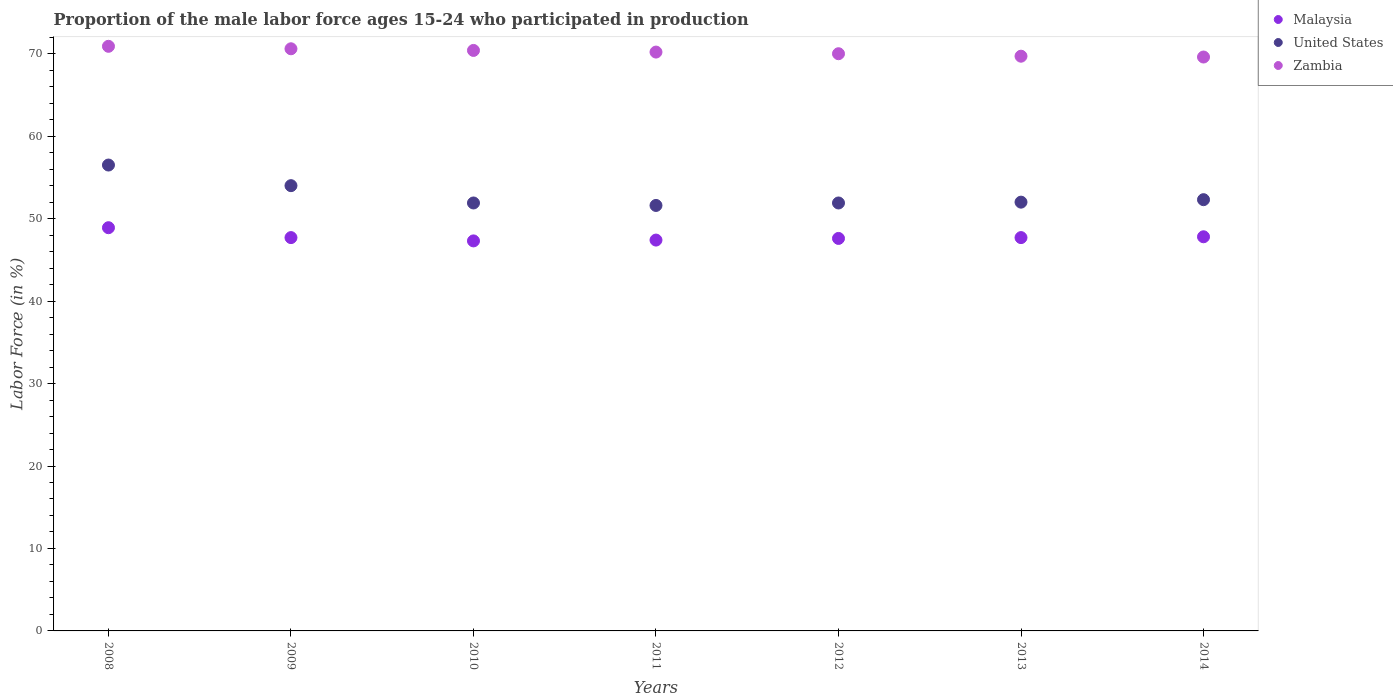How many different coloured dotlines are there?
Ensure brevity in your answer.  3. Is the number of dotlines equal to the number of legend labels?
Provide a succinct answer. Yes. What is the proportion of the male labor force who participated in production in United States in 2008?
Your response must be concise. 56.5. Across all years, what is the maximum proportion of the male labor force who participated in production in United States?
Give a very brief answer. 56.5. Across all years, what is the minimum proportion of the male labor force who participated in production in Zambia?
Your answer should be very brief. 69.6. In which year was the proportion of the male labor force who participated in production in Malaysia minimum?
Keep it short and to the point. 2010. What is the total proportion of the male labor force who participated in production in Zambia in the graph?
Provide a short and direct response. 491.4. What is the difference between the proportion of the male labor force who participated in production in United States in 2011 and the proportion of the male labor force who participated in production in Malaysia in 2008?
Make the answer very short. 2.7. What is the average proportion of the male labor force who participated in production in United States per year?
Give a very brief answer. 52.89. In the year 2011, what is the difference between the proportion of the male labor force who participated in production in Zambia and proportion of the male labor force who participated in production in United States?
Your response must be concise. 18.6. What is the ratio of the proportion of the male labor force who participated in production in United States in 2013 to that in 2014?
Offer a terse response. 0.99. Is the proportion of the male labor force who participated in production in Malaysia in 2013 less than that in 2014?
Provide a succinct answer. Yes. Is the difference between the proportion of the male labor force who participated in production in Zambia in 2009 and 2014 greater than the difference between the proportion of the male labor force who participated in production in United States in 2009 and 2014?
Your response must be concise. No. What is the difference between the highest and the second highest proportion of the male labor force who participated in production in Malaysia?
Your answer should be very brief. 1.1. What is the difference between the highest and the lowest proportion of the male labor force who participated in production in United States?
Give a very brief answer. 4.9. In how many years, is the proportion of the male labor force who participated in production in Zambia greater than the average proportion of the male labor force who participated in production in Zambia taken over all years?
Offer a very short reply. 3. Is it the case that in every year, the sum of the proportion of the male labor force who participated in production in United States and proportion of the male labor force who participated in production in Zambia  is greater than the proportion of the male labor force who participated in production in Malaysia?
Your answer should be compact. Yes. Is the proportion of the male labor force who participated in production in United States strictly greater than the proportion of the male labor force who participated in production in Zambia over the years?
Your answer should be compact. No. Is the proportion of the male labor force who participated in production in Zambia strictly less than the proportion of the male labor force who participated in production in United States over the years?
Give a very brief answer. No. How many years are there in the graph?
Make the answer very short. 7. Does the graph contain grids?
Your answer should be very brief. No. How many legend labels are there?
Offer a terse response. 3. How are the legend labels stacked?
Keep it short and to the point. Vertical. What is the title of the graph?
Provide a short and direct response. Proportion of the male labor force ages 15-24 who participated in production. What is the Labor Force (in %) of Malaysia in 2008?
Offer a very short reply. 48.9. What is the Labor Force (in %) of United States in 2008?
Provide a succinct answer. 56.5. What is the Labor Force (in %) of Zambia in 2008?
Keep it short and to the point. 70.9. What is the Labor Force (in %) in Malaysia in 2009?
Your answer should be compact. 47.7. What is the Labor Force (in %) in United States in 2009?
Give a very brief answer. 54. What is the Labor Force (in %) of Zambia in 2009?
Provide a succinct answer. 70.6. What is the Labor Force (in %) in Malaysia in 2010?
Offer a terse response. 47.3. What is the Labor Force (in %) of United States in 2010?
Your answer should be compact. 51.9. What is the Labor Force (in %) in Zambia in 2010?
Your answer should be compact. 70.4. What is the Labor Force (in %) in Malaysia in 2011?
Provide a short and direct response. 47.4. What is the Labor Force (in %) of United States in 2011?
Your answer should be very brief. 51.6. What is the Labor Force (in %) in Zambia in 2011?
Offer a terse response. 70.2. What is the Labor Force (in %) of Malaysia in 2012?
Your answer should be very brief. 47.6. What is the Labor Force (in %) of United States in 2012?
Your response must be concise. 51.9. What is the Labor Force (in %) of Malaysia in 2013?
Provide a succinct answer. 47.7. What is the Labor Force (in %) of United States in 2013?
Give a very brief answer. 52. What is the Labor Force (in %) of Zambia in 2013?
Offer a terse response. 69.7. What is the Labor Force (in %) of Malaysia in 2014?
Your answer should be very brief. 47.8. What is the Labor Force (in %) in United States in 2014?
Give a very brief answer. 52.3. What is the Labor Force (in %) of Zambia in 2014?
Ensure brevity in your answer.  69.6. Across all years, what is the maximum Labor Force (in %) in Malaysia?
Make the answer very short. 48.9. Across all years, what is the maximum Labor Force (in %) in United States?
Make the answer very short. 56.5. Across all years, what is the maximum Labor Force (in %) in Zambia?
Ensure brevity in your answer.  70.9. Across all years, what is the minimum Labor Force (in %) of Malaysia?
Your answer should be very brief. 47.3. Across all years, what is the minimum Labor Force (in %) of United States?
Offer a terse response. 51.6. Across all years, what is the minimum Labor Force (in %) in Zambia?
Offer a very short reply. 69.6. What is the total Labor Force (in %) of Malaysia in the graph?
Offer a terse response. 334.4. What is the total Labor Force (in %) in United States in the graph?
Give a very brief answer. 370.2. What is the total Labor Force (in %) of Zambia in the graph?
Your answer should be very brief. 491.4. What is the difference between the Labor Force (in %) of Malaysia in 2008 and that in 2009?
Your answer should be very brief. 1.2. What is the difference between the Labor Force (in %) of United States in 2008 and that in 2009?
Provide a short and direct response. 2.5. What is the difference between the Labor Force (in %) in United States in 2008 and that in 2010?
Give a very brief answer. 4.6. What is the difference between the Labor Force (in %) in Malaysia in 2008 and that in 2011?
Make the answer very short. 1.5. What is the difference between the Labor Force (in %) in Malaysia in 2008 and that in 2012?
Offer a very short reply. 1.3. What is the difference between the Labor Force (in %) in United States in 2008 and that in 2012?
Offer a very short reply. 4.6. What is the difference between the Labor Force (in %) in Malaysia in 2008 and that in 2013?
Give a very brief answer. 1.2. What is the difference between the Labor Force (in %) of United States in 2008 and that in 2013?
Your answer should be very brief. 4.5. What is the difference between the Labor Force (in %) of Malaysia in 2008 and that in 2014?
Your answer should be compact. 1.1. What is the difference between the Labor Force (in %) of Zambia in 2008 and that in 2014?
Your answer should be very brief. 1.3. What is the difference between the Labor Force (in %) in Malaysia in 2009 and that in 2010?
Offer a terse response. 0.4. What is the difference between the Labor Force (in %) in United States in 2009 and that in 2010?
Offer a very short reply. 2.1. What is the difference between the Labor Force (in %) of Zambia in 2009 and that in 2010?
Provide a succinct answer. 0.2. What is the difference between the Labor Force (in %) of United States in 2009 and that in 2011?
Keep it short and to the point. 2.4. What is the difference between the Labor Force (in %) of Zambia in 2009 and that in 2011?
Provide a succinct answer. 0.4. What is the difference between the Labor Force (in %) in Malaysia in 2009 and that in 2012?
Offer a very short reply. 0.1. What is the difference between the Labor Force (in %) of United States in 2009 and that in 2012?
Ensure brevity in your answer.  2.1. What is the difference between the Labor Force (in %) in Zambia in 2009 and that in 2012?
Provide a succinct answer. 0.6. What is the difference between the Labor Force (in %) of Malaysia in 2009 and that in 2013?
Provide a succinct answer. 0. What is the difference between the Labor Force (in %) of Zambia in 2009 and that in 2013?
Offer a terse response. 0.9. What is the difference between the Labor Force (in %) in Malaysia in 2009 and that in 2014?
Your answer should be compact. -0.1. What is the difference between the Labor Force (in %) of Zambia in 2009 and that in 2014?
Make the answer very short. 1. What is the difference between the Labor Force (in %) of Zambia in 2010 and that in 2011?
Ensure brevity in your answer.  0.2. What is the difference between the Labor Force (in %) in Malaysia in 2010 and that in 2012?
Your answer should be compact. -0.3. What is the difference between the Labor Force (in %) of Zambia in 2010 and that in 2012?
Keep it short and to the point. 0.4. What is the difference between the Labor Force (in %) in Malaysia in 2010 and that in 2013?
Ensure brevity in your answer.  -0.4. What is the difference between the Labor Force (in %) of Zambia in 2010 and that in 2013?
Give a very brief answer. 0.7. What is the difference between the Labor Force (in %) of Malaysia in 2010 and that in 2014?
Provide a succinct answer. -0.5. What is the difference between the Labor Force (in %) in United States in 2010 and that in 2014?
Your answer should be very brief. -0.4. What is the difference between the Labor Force (in %) of United States in 2011 and that in 2012?
Offer a very short reply. -0.3. What is the difference between the Labor Force (in %) in Zambia in 2011 and that in 2013?
Offer a very short reply. 0.5. What is the difference between the Labor Force (in %) in Malaysia in 2011 and that in 2014?
Offer a very short reply. -0.4. What is the difference between the Labor Force (in %) of Zambia in 2011 and that in 2014?
Make the answer very short. 0.6. What is the difference between the Labor Force (in %) of Malaysia in 2012 and that in 2013?
Ensure brevity in your answer.  -0.1. What is the difference between the Labor Force (in %) of United States in 2012 and that in 2013?
Your response must be concise. -0.1. What is the difference between the Labor Force (in %) of Zambia in 2012 and that in 2013?
Keep it short and to the point. 0.3. What is the difference between the Labor Force (in %) in Malaysia in 2012 and that in 2014?
Give a very brief answer. -0.2. What is the difference between the Labor Force (in %) in Zambia in 2012 and that in 2014?
Keep it short and to the point. 0.4. What is the difference between the Labor Force (in %) in Zambia in 2013 and that in 2014?
Offer a terse response. 0.1. What is the difference between the Labor Force (in %) in Malaysia in 2008 and the Labor Force (in %) in United States in 2009?
Provide a short and direct response. -5.1. What is the difference between the Labor Force (in %) of Malaysia in 2008 and the Labor Force (in %) of Zambia in 2009?
Your answer should be compact. -21.7. What is the difference between the Labor Force (in %) in United States in 2008 and the Labor Force (in %) in Zambia in 2009?
Your answer should be compact. -14.1. What is the difference between the Labor Force (in %) of Malaysia in 2008 and the Labor Force (in %) of Zambia in 2010?
Give a very brief answer. -21.5. What is the difference between the Labor Force (in %) of United States in 2008 and the Labor Force (in %) of Zambia in 2010?
Your answer should be compact. -13.9. What is the difference between the Labor Force (in %) in Malaysia in 2008 and the Labor Force (in %) in Zambia in 2011?
Your answer should be very brief. -21.3. What is the difference between the Labor Force (in %) in United States in 2008 and the Labor Force (in %) in Zambia in 2011?
Make the answer very short. -13.7. What is the difference between the Labor Force (in %) in Malaysia in 2008 and the Labor Force (in %) in United States in 2012?
Offer a terse response. -3. What is the difference between the Labor Force (in %) of Malaysia in 2008 and the Labor Force (in %) of Zambia in 2012?
Give a very brief answer. -21.1. What is the difference between the Labor Force (in %) in Malaysia in 2008 and the Labor Force (in %) in Zambia in 2013?
Give a very brief answer. -20.8. What is the difference between the Labor Force (in %) in Malaysia in 2008 and the Labor Force (in %) in United States in 2014?
Give a very brief answer. -3.4. What is the difference between the Labor Force (in %) in Malaysia in 2008 and the Labor Force (in %) in Zambia in 2014?
Ensure brevity in your answer.  -20.7. What is the difference between the Labor Force (in %) of Malaysia in 2009 and the Labor Force (in %) of Zambia in 2010?
Give a very brief answer. -22.7. What is the difference between the Labor Force (in %) in United States in 2009 and the Labor Force (in %) in Zambia in 2010?
Your response must be concise. -16.4. What is the difference between the Labor Force (in %) in Malaysia in 2009 and the Labor Force (in %) in United States in 2011?
Your answer should be compact. -3.9. What is the difference between the Labor Force (in %) in Malaysia in 2009 and the Labor Force (in %) in Zambia in 2011?
Your answer should be very brief. -22.5. What is the difference between the Labor Force (in %) in United States in 2009 and the Labor Force (in %) in Zambia in 2011?
Your answer should be very brief. -16.2. What is the difference between the Labor Force (in %) in Malaysia in 2009 and the Labor Force (in %) in Zambia in 2012?
Give a very brief answer. -22.3. What is the difference between the Labor Force (in %) in United States in 2009 and the Labor Force (in %) in Zambia in 2012?
Keep it short and to the point. -16. What is the difference between the Labor Force (in %) of Malaysia in 2009 and the Labor Force (in %) of United States in 2013?
Your response must be concise. -4.3. What is the difference between the Labor Force (in %) of United States in 2009 and the Labor Force (in %) of Zambia in 2013?
Ensure brevity in your answer.  -15.7. What is the difference between the Labor Force (in %) in Malaysia in 2009 and the Labor Force (in %) in Zambia in 2014?
Your answer should be compact. -21.9. What is the difference between the Labor Force (in %) of United States in 2009 and the Labor Force (in %) of Zambia in 2014?
Your response must be concise. -15.6. What is the difference between the Labor Force (in %) in Malaysia in 2010 and the Labor Force (in %) in United States in 2011?
Make the answer very short. -4.3. What is the difference between the Labor Force (in %) of Malaysia in 2010 and the Labor Force (in %) of Zambia in 2011?
Offer a terse response. -22.9. What is the difference between the Labor Force (in %) of United States in 2010 and the Labor Force (in %) of Zambia in 2011?
Provide a succinct answer. -18.3. What is the difference between the Labor Force (in %) of Malaysia in 2010 and the Labor Force (in %) of United States in 2012?
Your answer should be compact. -4.6. What is the difference between the Labor Force (in %) in Malaysia in 2010 and the Labor Force (in %) in Zambia in 2012?
Ensure brevity in your answer.  -22.7. What is the difference between the Labor Force (in %) in United States in 2010 and the Labor Force (in %) in Zambia in 2012?
Provide a short and direct response. -18.1. What is the difference between the Labor Force (in %) in Malaysia in 2010 and the Labor Force (in %) in Zambia in 2013?
Your response must be concise. -22.4. What is the difference between the Labor Force (in %) of United States in 2010 and the Labor Force (in %) of Zambia in 2013?
Keep it short and to the point. -17.8. What is the difference between the Labor Force (in %) in Malaysia in 2010 and the Labor Force (in %) in Zambia in 2014?
Ensure brevity in your answer.  -22.3. What is the difference between the Labor Force (in %) in United States in 2010 and the Labor Force (in %) in Zambia in 2014?
Ensure brevity in your answer.  -17.7. What is the difference between the Labor Force (in %) in Malaysia in 2011 and the Labor Force (in %) in United States in 2012?
Provide a succinct answer. -4.5. What is the difference between the Labor Force (in %) in Malaysia in 2011 and the Labor Force (in %) in Zambia in 2012?
Your answer should be very brief. -22.6. What is the difference between the Labor Force (in %) of United States in 2011 and the Labor Force (in %) of Zambia in 2012?
Provide a short and direct response. -18.4. What is the difference between the Labor Force (in %) of Malaysia in 2011 and the Labor Force (in %) of United States in 2013?
Ensure brevity in your answer.  -4.6. What is the difference between the Labor Force (in %) in Malaysia in 2011 and the Labor Force (in %) in Zambia in 2013?
Offer a very short reply. -22.3. What is the difference between the Labor Force (in %) of United States in 2011 and the Labor Force (in %) of Zambia in 2013?
Make the answer very short. -18.1. What is the difference between the Labor Force (in %) of Malaysia in 2011 and the Labor Force (in %) of United States in 2014?
Offer a terse response. -4.9. What is the difference between the Labor Force (in %) in Malaysia in 2011 and the Labor Force (in %) in Zambia in 2014?
Offer a very short reply. -22.2. What is the difference between the Labor Force (in %) of Malaysia in 2012 and the Labor Force (in %) of United States in 2013?
Give a very brief answer. -4.4. What is the difference between the Labor Force (in %) of Malaysia in 2012 and the Labor Force (in %) of Zambia in 2013?
Provide a short and direct response. -22.1. What is the difference between the Labor Force (in %) of United States in 2012 and the Labor Force (in %) of Zambia in 2013?
Make the answer very short. -17.8. What is the difference between the Labor Force (in %) of Malaysia in 2012 and the Labor Force (in %) of United States in 2014?
Ensure brevity in your answer.  -4.7. What is the difference between the Labor Force (in %) in United States in 2012 and the Labor Force (in %) in Zambia in 2014?
Your answer should be compact. -17.7. What is the difference between the Labor Force (in %) in Malaysia in 2013 and the Labor Force (in %) in Zambia in 2014?
Offer a very short reply. -21.9. What is the difference between the Labor Force (in %) of United States in 2013 and the Labor Force (in %) of Zambia in 2014?
Keep it short and to the point. -17.6. What is the average Labor Force (in %) in Malaysia per year?
Ensure brevity in your answer.  47.77. What is the average Labor Force (in %) in United States per year?
Provide a succinct answer. 52.89. What is the average Labor Force (in %) of Zambia per year?
Provide a short and direct response. 70.2. In the year 2008, what is the difference between the Labor Force (in %) of United States and Labor Force (in %) of Zambia?
Provide a succinct answer. -14.4. In the year 2009, what is the difference between the Labor Force (in %) in Malaysia and Labor Force (in %) in Zambia?
Keep it short and to the point. -22.9. In the year 2009, what is the difference between the Labor Force (in %) in United States and Labor Force (in %) in Zambia?
Provide a succinct answer. -16.6. In the year 2010, what is the difference between the Labor Force (in %) of Malaysia and Labor Force (in %) of Zambia?
Ensure brevity in your answer.  -23.1. In the year 2010, what is the difference between the Labor Force (in %) of United States and Labor Force (in %) of Zambia?
Your answer should be very brief. -18.5. In the year 2011, what is the difference between the Labor Force (in %) of Malaysia and Labor Force (in %) of United States?
Offer a terse response. -4.2. In the year 2011, what is the difference between the Labor Force (in %) in Malaysia and Labor Force (in %) in Zambia?
Provide a short and direct response. -22.8. In the year 2011, what is the difference between the Labor Force (in %) in United States and Labor Force (in %) in Zambia?
Provide a succinct answer. -18.6. In the year 2012, what is the difference between the Labor Force (in %) in Malaysia and Labor Force (in %) in United States?
Ensure brevity in your answer.  -4.3. In the year 2012, what is the difference between the Labor Force (in %) of Malaysia and Labor Force (in %) of Zambia?
Offer a very short reply. -22.4. In the year 2012, what is the difference between the Labor Force (in %) of United States and Labor Force (in %) of Zambia?
Keep it short and to the point. -18.1. In the year 2013, what is the difference between the Labor Force (in %) of Malaysia and Labor Force (in %) of United States?
Offer a terse response. -4.3. In the year 2013, what is the difference between the Labor Force (in %) in Malaysia and Labor Force (in %) in Zambia?
Provide a short and direct response. -22. In the year 2013, what is the difference between the Labor Force (in %) of United States and Labor Force (in %) of Zambia?
Keep it short and to the point. -17.7. In the year 2014, what is the difference between the Labor Force (in %) in Malaysia and Labor Force (in %) in Zambia?
Provide a succinct answer. -21.8. In the year 2014, what is the difference between the Labor Force (in %) of United States and Labor Force (in %) of Zambia?
Your answer should be very brief. -17.3. What is the ratio of the Labor Force (in %) in Malaysia in 2008 to that in 2009?
Give a very brief answer. 1.03. What is the ratio of the Labor Force (in %) in United States in 2008 to that in 2009?
Your answer should be compact. 1.05. What is the ratio of the Labor Force (in %) in Zambia in 2008 to that in 2009?
Give a very brief answer. 1. What is the ratio of the Labor Force (in %) in Malaysia in 2008 to that in 2010?
Make the answer very short. 1.03. What is the ratio of the Labor Force (in %) of United States in 2008 to that in 2010?
Your answer should be very brief. 1.09. What is the ratio of the Labor Force (in %) of Zambia in 2008 to that in 2010?
Give a very brief answer. 1.01. What is the ratio of the Labor Force (in %) of Malaysia in 2008 to that in 2011?
Make the answer very short. 1.03. What is the ratio of the Labor Force (in %) of United States in 2008 to that in 2011?
Provide a succinct answer. 1.09. What is the ratio of the Labor Force (in %) in Malaysia in 2008 to that in 2012?
Your answer should be very brief. 1.03. What is the ratio of the Labor Force (in %) in United States in 2008 to that in 2012?
Keep it short and to the point. 1.09. What is the ratio of the Labor Force (in %) in Zambia in 2008 to that in 2012?
Give a very brief answer. 1.01. What is the ratio of the Labor Force (in %) in Malaysia in 2008 to that in 2013?
Your answer should be compact. 1.03. What is the ratio of the Labor Force (in %) of United States in 2008 to that in 2013?
Keep it short and to the point. 1.09. What is the ratio of the Labor Force (in %) of Zambia in 2008 to that in 2013?
Your answer should be compact. 1.02. What is the ratio of the Labor Force (in %) of United States in 2008 to that in 2014?
Keep it short and to the point. 1.08. What is the ratio of the Labor Force (in %) in Zambia in 2008 to that in 2014?
Offer a very short reply. 1.02. What is the ratio of the Labor Force (in %) in Malaysia in 2009 to that in 2010?
Give a very brief answer. 1.01. What is the ratio of the Labor Force (in %) of United States in 2009 to that in 2010?
Your answer should be compact. 1.04. What is the ratio of the Labor Force (in %) in Zambia in 2009 to that in 2010?
Your response must be concise. 1. What is the ratio of the Labor Force (in %) of Malaysia in 2009 to that in 2011?
Your response must be concise. 1.01. What is the ratio of the Labor Force (in %) in United States in 2009 to that in 2011?
Offer a very short reply. 1.05. What is the ratio of the Labor Force (in %) in Zambia in 2009 to that in 2011?
Offer a terse response. 1.01. What is the ratio of the Labor Force (in %) of Malaysia in 2009 to that in 2012?
Your answer should be very brief. 1. What is the ratio of the Labor Force (in %) in United States in 2009 to that in 2012?
Provide a succinct answer. 1.04. What is the ratio of the Labor Force (in %) in Zambia in 2009 to that in 2012?
Your response must be concise. 1.01. What is the ratio of the Labor Force (in %) in United States in 2009 to that in 2013?
Your answer should be very brief. 1.04. What is the ratio of the Labor Force (in %) in Zambia in 2009 to that in 2013?
Give a very brief answer. 1.01. What is the ratio of the Labor Force (in %) in United States in 2009 to that in 2014?
Your answer should be very brief. 1.03. What is the ratio of the Labor Force (in %) in Zambia in 2009 to that in 2014?
Offer a very short reply. 1.01. What is the ratio of the Labor Force (in %) of Malaysia in 2010 to that in 2011?
Keep it short and to the point. 1. What is the ratio of the Labor Force (in %) of United States in 2010 to that in 2011?
Your response must be concise. 1.01. What is the ratio of the Labor Force (in %) of United States in 2010 to that in 2012?
Your response must be concise. 1. What is the ratio of the Labor Force (in %) of Zambia in 2010 to that in 2012?
Provide a succinct answer. 1.01. What is the ratio of the Labor Force (in %) of United States in 2010 to that in 2013?
Give a very brief answer. 1. What is the ratio of the Labor Force (in %) in Zambia in 2010 to that in 2013?
Your answer should be very brief. 1.01. What is the ratio of the Labor Force (in %) in Zambia in 2010 to that in 2014?
Provide a short and direct response. 1.01. What is the ratio of the Labor Force (in %) in Malaysia in 2011 to that in 2012?
Your answer should be very brief. 1. What is the ratio of the Labor Force (in %) of Zambia in 2011 to that in 2012?
Provide a succinct answer. 1. What is the ratio of the Labor Force (in %) of United States in 2011 to that in 2013?
Make the answer very short. 0.99. What is the ratio of the Labor Force (in %) in Zambia in 2011 to that in 2013?
Provide a succinct answer. 1.01. What is the ratio of the Labor Force (in %) in Malaysia in 2011 to that in 2014?
Provide a short and direct response. 0.99. What is the ratio of the Labor Force (in %) in United States in 2011 to that in 2014?
Offer a terse response. 0.99. What is the ratio of the Labor Force (in %) in Zambia in 2011 to that in 2014?
Provide a succinct answer. 1.01. What is the ratio of the Labor Force (in %) in Zambia in 2012 to that in 2014?
Offer a terse response. 1.01. What is the ratio of the Labor Force (in %) of Malaysia in 2013 to that in 2014?
Give a very brief answer. 1. What is the ratio of the Labor Force (in %) of United States in 2013 to that in 2014?
Provide a short and direct response. 0.99. What is the ratio of the Labor Force (in %) of Zambia in 2013 to that in 2014?
Provide a short and direct response. 1. What is the difference between the highest and the second highest Labor Force (in %) of Zambia?
Offer a very short reply. 0.3. What is the difference between the highest and the lowest Labor Force (in %) in United States?
Give a very brief answer. 4.9. 